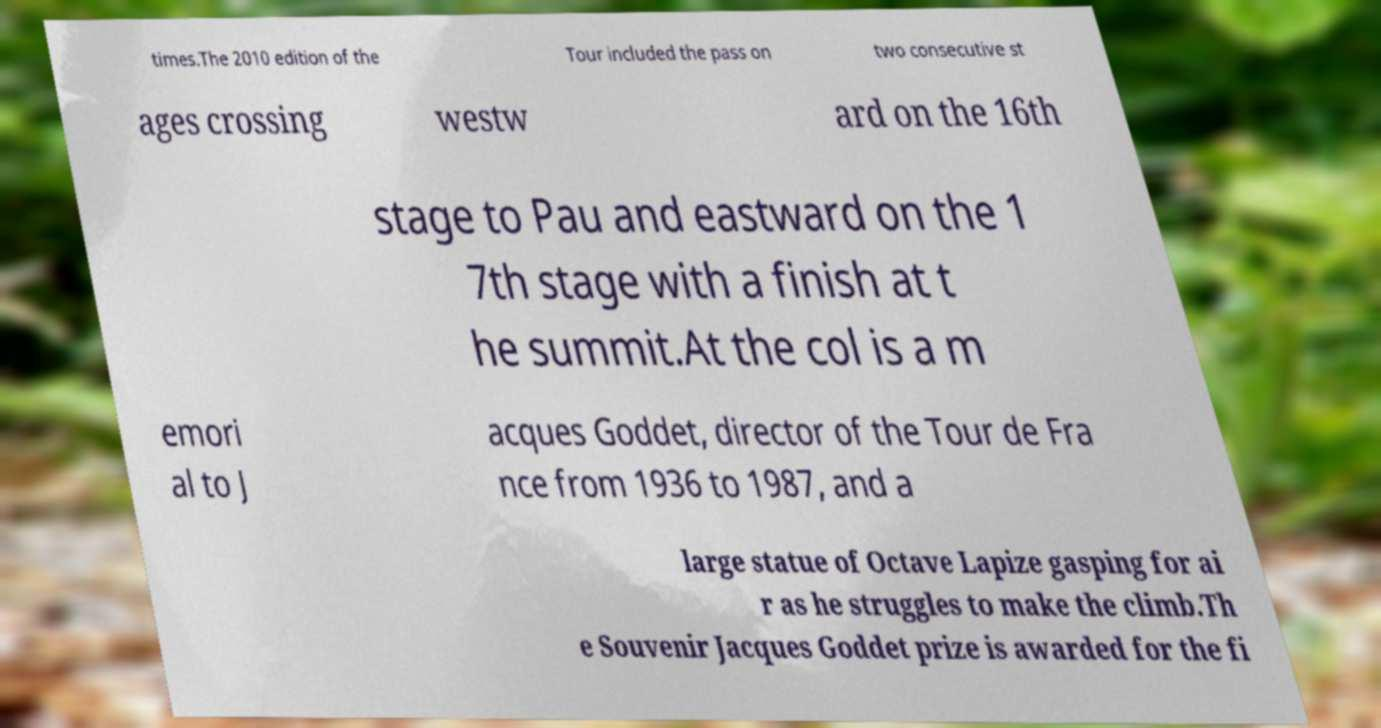Could you assist in decoding the text presented in this image and type it out clearly? times.The 2010 edition of the Tour included the pass on two consecutive st ages crossing westw ard on the 16th stage to Pau and eastward on the 1 7th stage with a finish at t he summit.At the col is a m emori al to J acques Goddet, director of the Tour de Fra nce from 1936 to 1987, and a large statue of Octave Lapize gasping for ai r as he struggles to make the climb.Th e Souvenir Jacques Goddet prize is awarded for the fi 